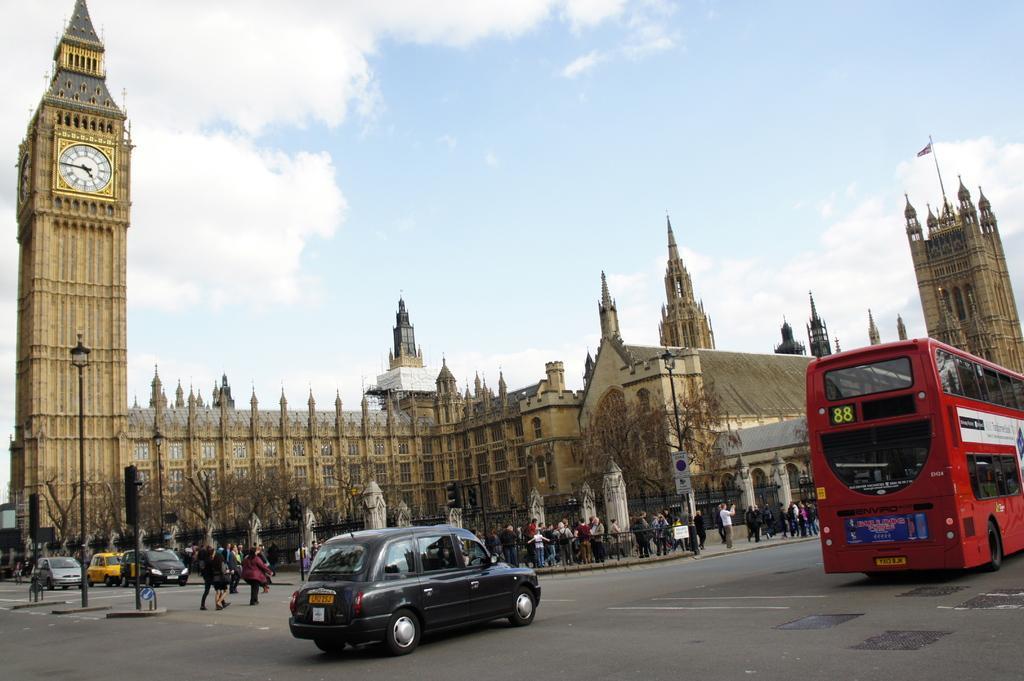Please provide a concise description of this image. In this picture I can see group of people standing, there are boards, poles, lights, trees, buildings, there is a tower with blocks, there are vehicles on the road, and in the background there is sky. 